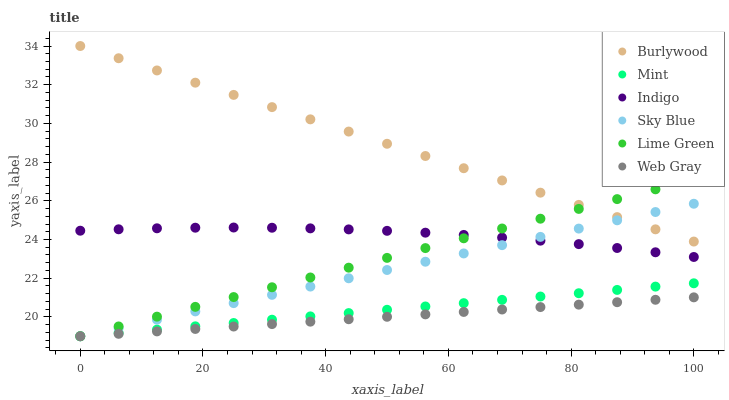Does Web Gray have the minimum area under the curve?
Answer yes or no. Yes. Does Burlywood have the maximum area under the curve?
Answer yes or no. Yes. Does Indigo have the minimum area under the curve?
Answer yes or no. No. Does Indigo have the maximum area under the curve?
Answer yes or no. No. Is Lime Green the smoothest?
Answer yes or no. Yes. Is Indigo the roughest?
Answer yes or no. Yes. Is Burlywood the smoothest?
Answer yes or no. No. Is Burlywood the roughest?
Answer yes or no. No. Does Web Gray have the lowest value?
Answer yes or no. Yes. Does Indigo have the lowest value?
Answer yes or no. No. Does Burlywood have the highest value?
Answer yes or no. Yes. Does Indigo have the highest value?
Answer yes or no. No. Is Mint less than Indigo?
Answer yes or no. Yes. Is Indigo greater than Mint?
Answer yes or no. Yes. Does Burlywood intersect Lime Green?
Answer yes or no. Yes. Is Burlywood less than Lime Green?
Answer yes or no. No. Is Burlywood greater than Lime Green?
Answer yes or no. No. Does Mint intersect Indigo?
Answer yes or no. No. 